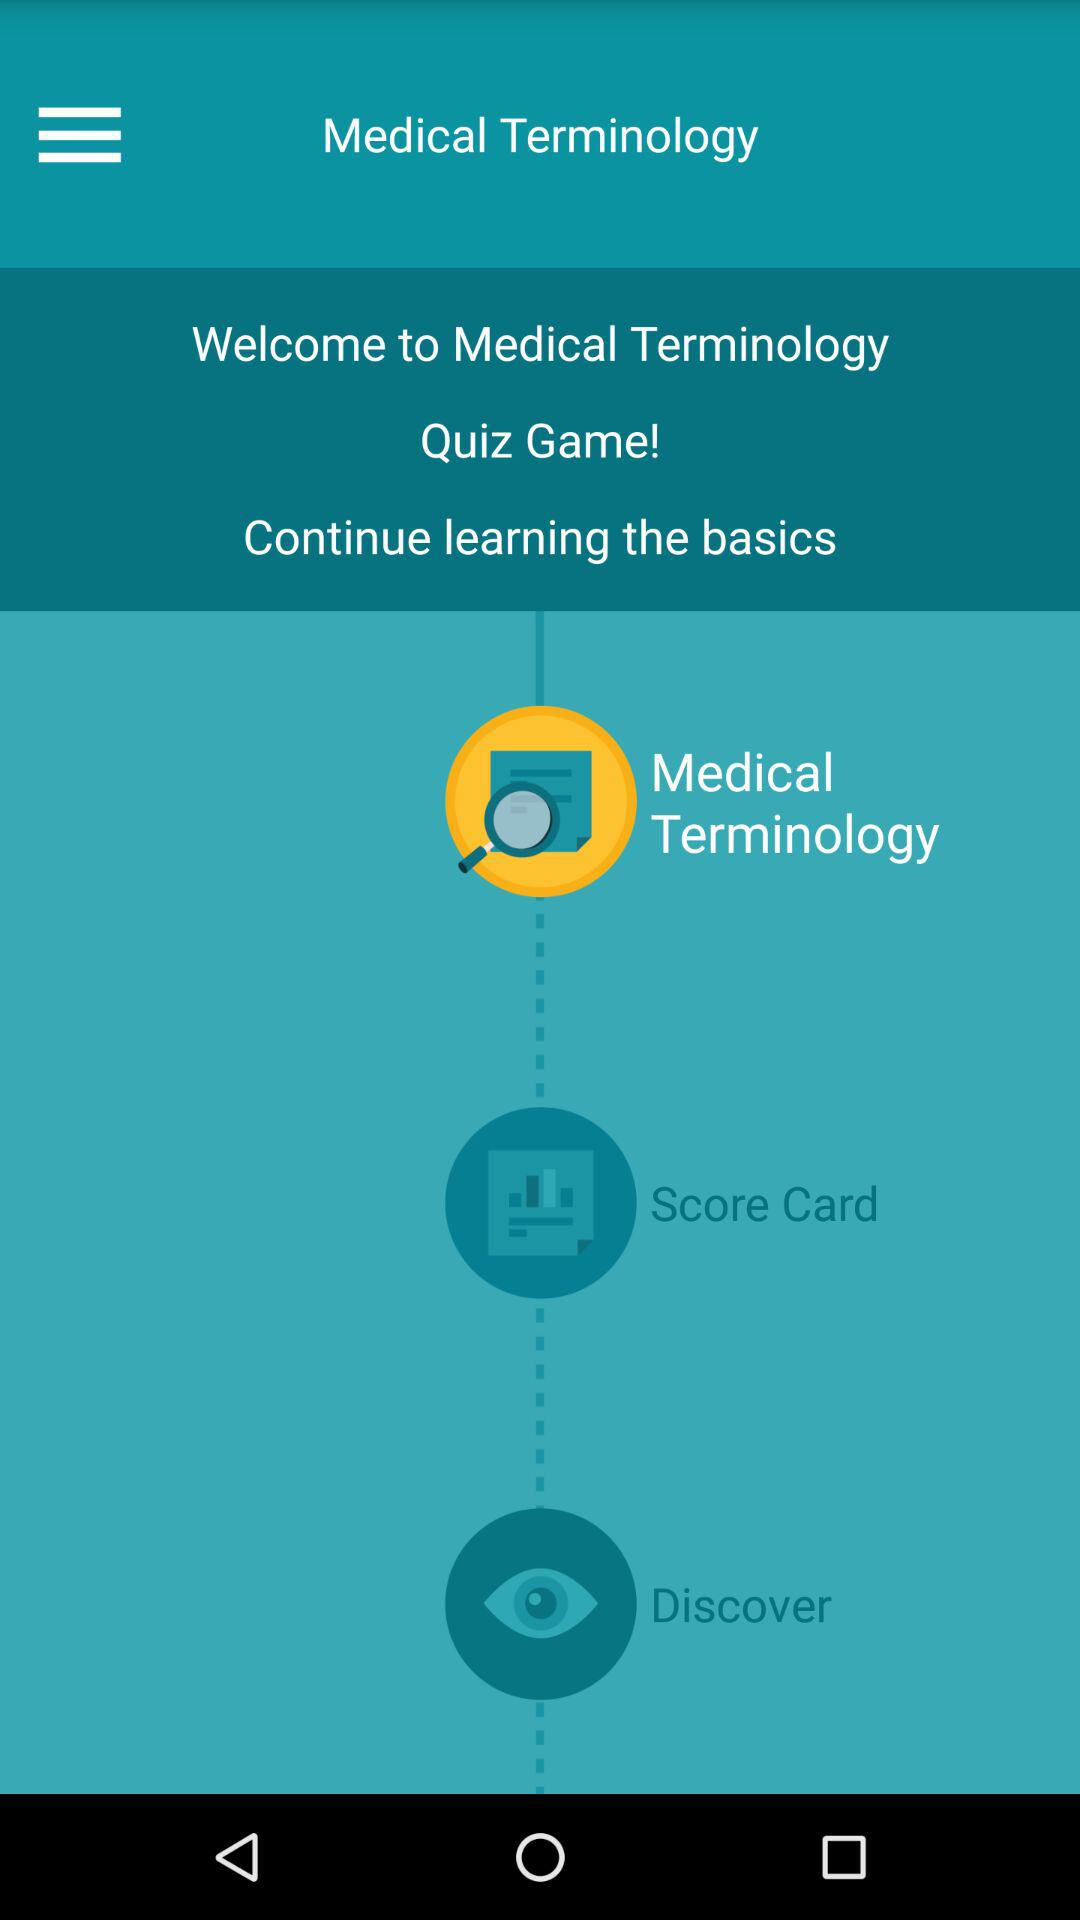What is the name of the quiz game? The name of the quiz game is "Medical Terminology". 